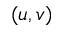<formula> <loc_0><loc_0><loc_500><loc_500>( u , v )</formula> 